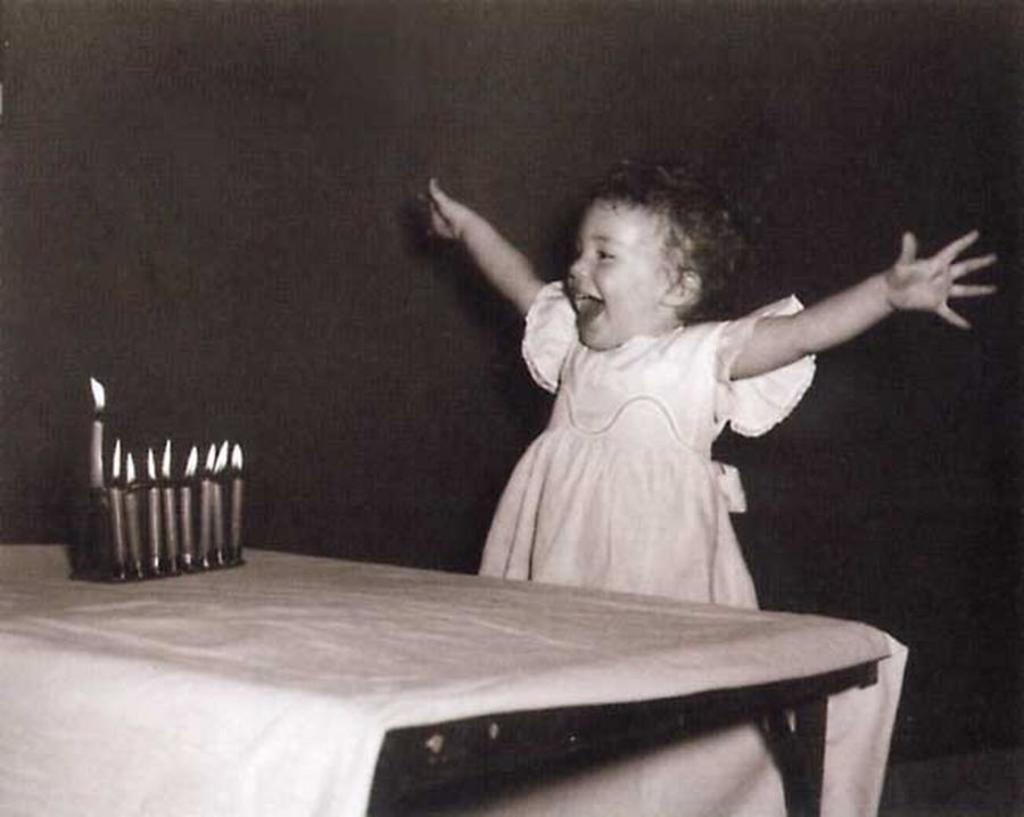Please provide a concise description of this image. A girl is standing and laughing and there are candles on the table. 